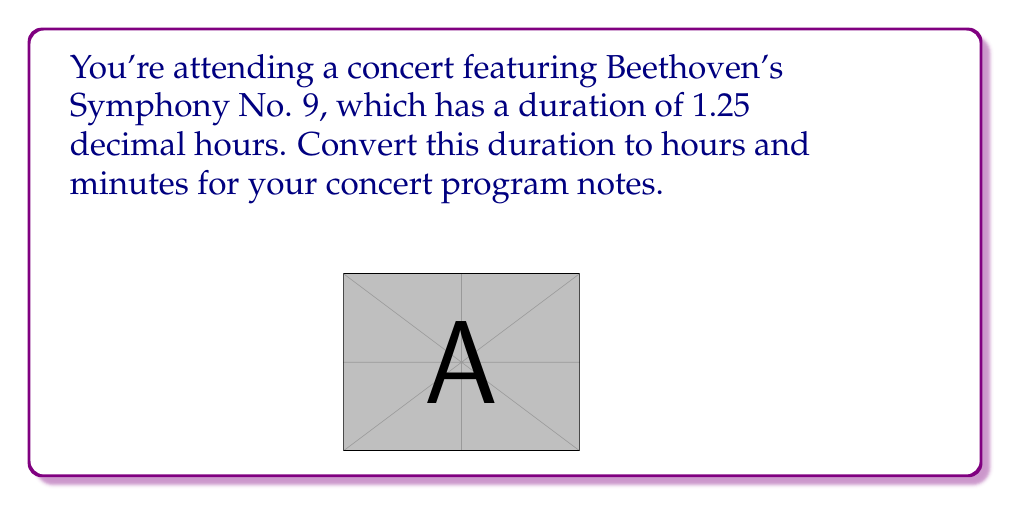Give your solution to this math problem. Let's convert 1.25 decimal hours to hours and minutes:

1. Separate the whole number and decimal parts:
   $1.25 = 1 + 0.25$

2. The whole number (1) represents the complete hours.

3. Convert the decimal part (0.25) to minutes:
   $0.25 \text{ hours} = 0.25 \times 60 \text{ minutes}$
   $= 15 \text{ minutes}$

4. Combine the results:
   $1 \text{ hour} + 15 \text{ minutes} = 1:15$

Therefore, 1.25 decimal hours is equivalent to 1 hour and 15 minutes.
Answer: 1 hour 15 minutes 